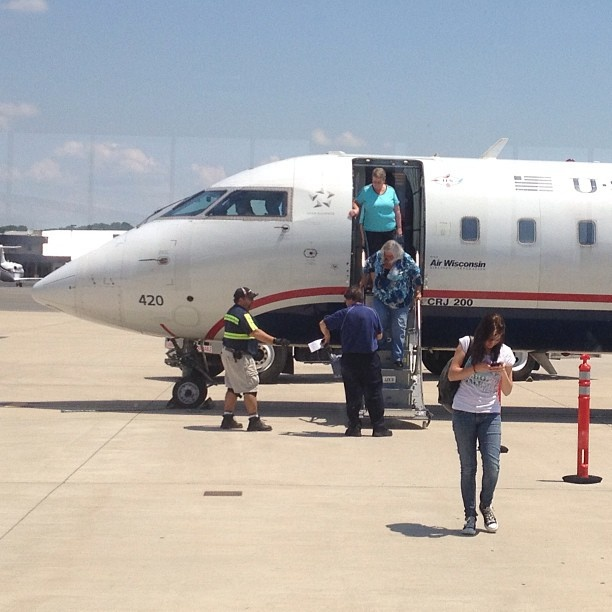Describe the objects in this image and their specific colors. I can see airplane in darkgray, white, black, and gray tones, people in darkgray, black, and gray tones, people in darkgray, black, navy, gray, and blue tones, people in darkgray, black, and gray tones, and people in darkgray, navy, gray, black, and darkblue tones in this image. 